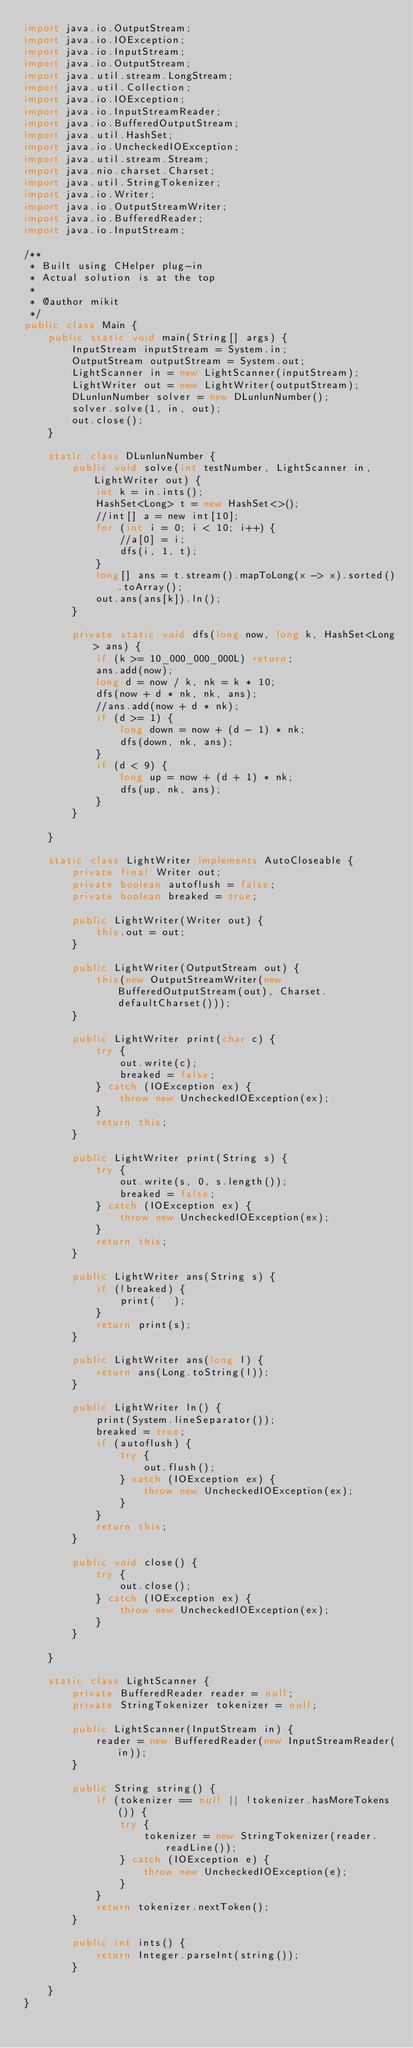Convert code to text. <code><loc_0><loc_0><loc_500><loc_500><_Java_>import java.io.OutputStream;
import java.io.IOException;
import java.io.InputStream;
import java.io.OutputStream;
import java.util.stream.LongStream;
import java.util.Collection;
import java.io.IOException;
import java.io.InputStreamReader;
import java.io.BufferedOutputStream;
import java.util.HashSet;
import java.io.UncheckedIOException;
import java.util.stream.Stream;
import java.nio.charset.Charset;
import java.util.StringTokenizer;
import java.io.Writer;
import java.io.OutputStreamWriter;
import java.io.BufferedReader;
import java.io.InputStream;

/**
 * Built using CHelper plug-in
 * Actual solution is at the top
 *
 * @author mikit
 */
public class Main {
    public static void main(String[] args) {
        InputStream inputStream = System.in;
        OutputStream outputStream = System.out;
        LightScanner in = new LightScanner(inputStream);
        LightWriter out = new LightWriter(outputStream);
        DLunlunNumber solver = new DLunlunNumber();
        solver.solve(1, in, out);
        out.close();
    }

    static class DLunlunNumber {
        public void solve(int testNumber, LightScanner in, LightWriter out) {
            int k = in.ints();
            HashSet<Long> t = new HashSet<>();
            //int[] a = new int[10];
            for (int i = 0; i < 10; i++) {
                //a[0] = i;
                dfs(i, 1, t);
            }
            long[] ans = t.stream().mapToLong(x -> x).sorted().toArray();
            out.ans(ans[k]).ln();
        }

        private static void dfs(long now, long k, HashSet<Long> ans) {
            if (k >= 10_000_000_000L) return;
            ans.add(now);
            long d = now / k, nk = k * 10;
            dfs(now + d * nk, nk, ans);
            //ans.add(now + d * nk);
            if (d >= 1) {
                long down = now + (d - 1) * nk;
                dfs(down, nk, ans);
            }
            if (d < 9) {
                long up = now + (d + 1) * nk;
                dfs(up, nk, ans);
            }
        }

    }

    static class LightWriter implements AutoCloseable {
        private final Writer out;
        private boolean autoflush = false;
        private boolean breaked = true;

        public LightWriter(Writer out) {
            this.out = out;
        }

        public LightWriter(OutputStream out) {
            this(new OutputStreamWriter(new BufferedOutputStream(out), Charset.defaultCharset()));
        }

        public LightWriter print(char c) {
            try {
                out.write(c);
                breaked = false;
            } catch (IOException ex) {
                throw new UncheckedIOException(ex);
            }
            return this;
        }

        public LightWriter print(String s) {
            try {
                out.write(s, 0, s.length());
                breaked = false;
            } catch (IOException ex) {
                throw new UncheckedIOException(ex);
            }
            return this;
        }

        public LightWriter ans(String s) {
            if (!breaked) {
                print(' ');
            }
            return print(s);
        }

        public LightWriter ans(long l) {
            return ans(Long.toString(l));
        }

        public LightWriter ln() {
            print(System.lineSeparator());
            breaked = true;
            if (autoflush) {
                try {
                    out.flush();
                } catch (IOException ex) {
                    throw new UncheckedIOException(ex);
                }
            }
            return this;
        }

        public void close() {
            try {
                out.close();
            } catch (IOException ex) {
                throw new UncheckedIOException(ex);
            }
        }

    }

    static class LightScanner {
        private BufferedReader reader = null;
        private StringTokenizer tokenizer = null;

        public LightScanner(InputStream in) {
            reader = new BufferedReader(new InputStreamReader(in));
        }

        public String string() {
            if (tokenizer == null || !tokenizer.hasMoreTokens()) {
                try {
                    tokenizer = new StringTokenizer(reader.readLine());
                } catch (IOException e) {
                    throw new UncheckedIOException(e);
                }
            }
            return tokenizer.nextToken();
        }

        public int ints() {
            return Integer.parseInt(string());
        }

    }
}

</code> 